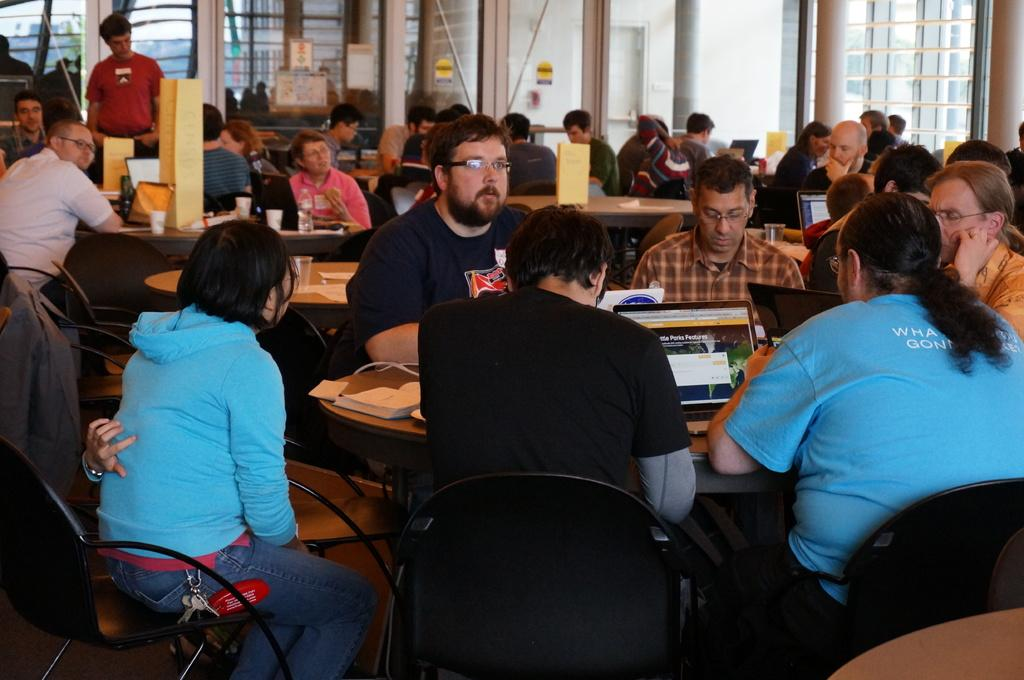What are the persons in the image doing? The persons in the image are sitting on chairs. What can be seen on the table in the image? There is a laptop and a book on the table. Can you describe the table's location in the image? The table is located between the persons sitting on chairs. What architectural features are present in the image? There is a door and a pillar in the image. What type of tin can be seen on the table in the image? There is no tin present on the table in the image. Is there a lock on the door in the image? The image does not show a lock on the door, only the door itself. 